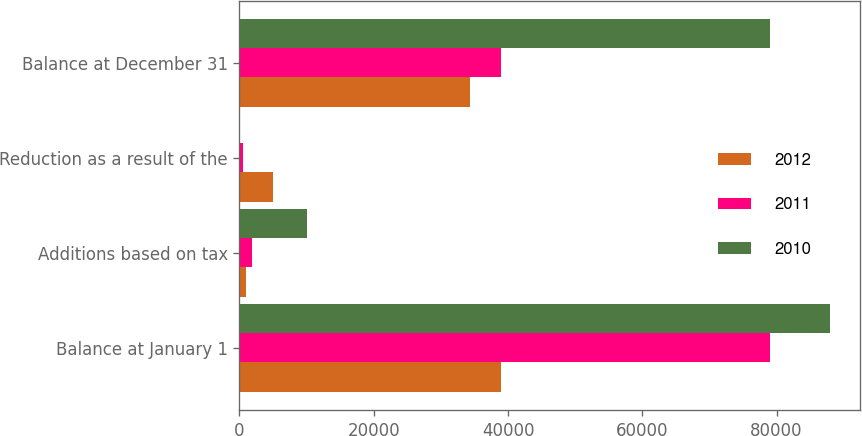Convert chart. <chart><loc_0><loc_0><loc_500><loc_500><stacked_bar_chart><ecel><fcel>Balance at January 1<fcel>Additions based on tax<fcel>Reduction as a result of the<fcel>Balance at December 31<nl><fcel>2012<fcel>38886<fcel>1037<fcel>4926<fcel>34337<nl><fcel>2011<fcel>79012<fcel>1801<fcel>467<fcel>38886<nl><fcel>2010<fcel>87975<fcel>10101<fcel>53<fcel>79012<nl></chart> 